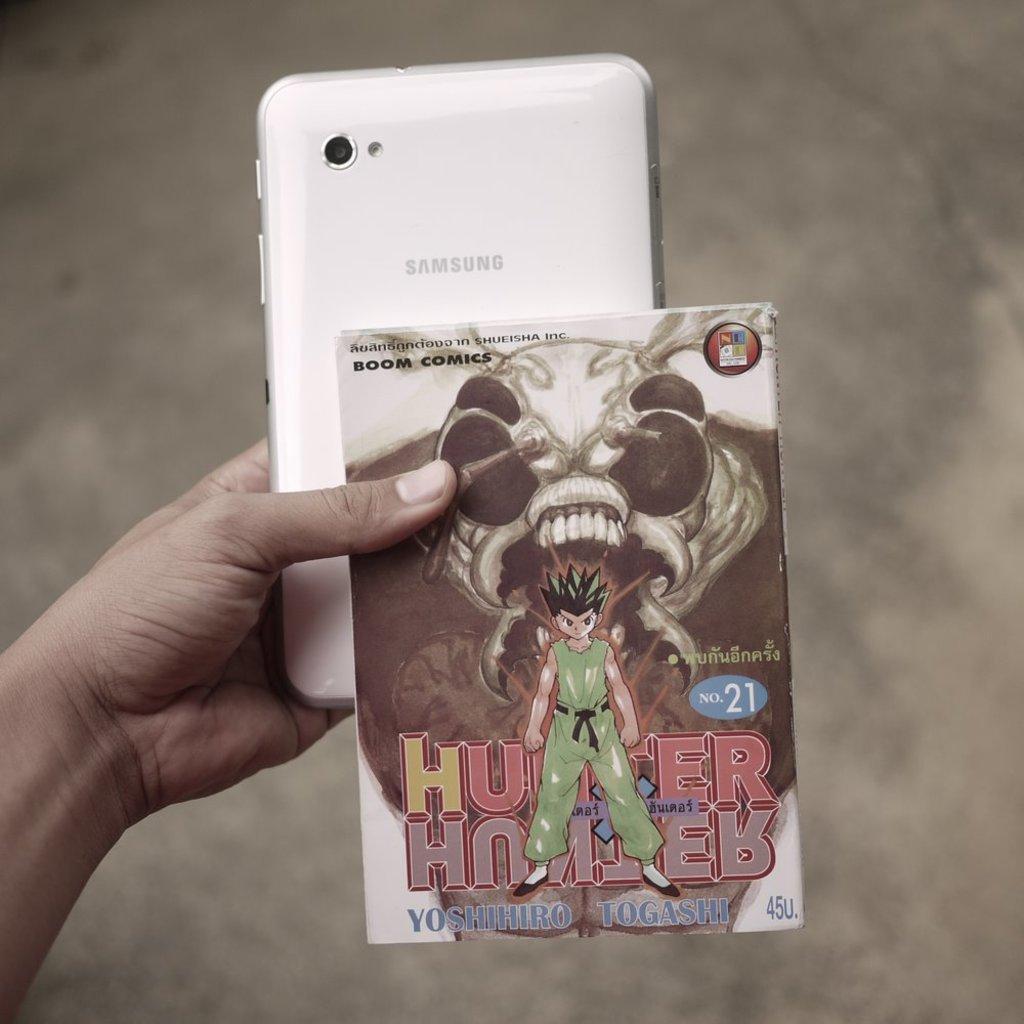Can you describe this image briefly? In this image we can see a person holding a mobile phone and a card in the hand. 